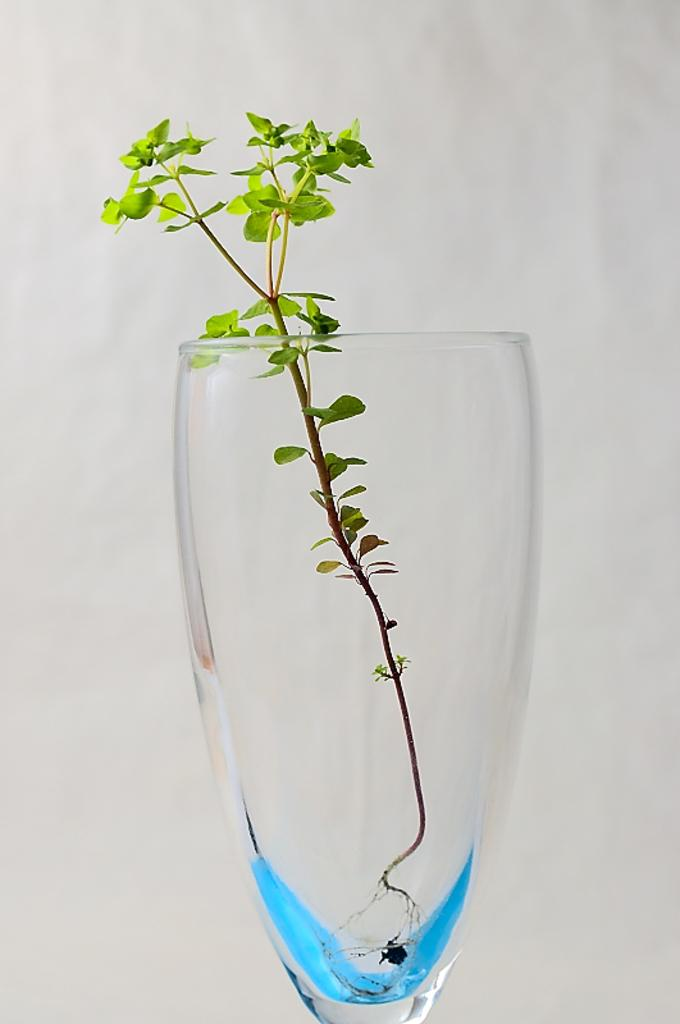What object is present in the image that can hold liquid? There is a glass in the image. What is inside the glass in the image? There is a plant in the glass. What color is the background of the image? The background of the image is white. What type of thought is being expressed by the plant in the image? There is no indication in the image that the plant is expressing any thoughts, as plants do not have the ability to think or express thoughts. 